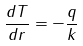Convert formula to latex. <formula><loc_0><loc_0><loc_500><loc_500>\frac { d T } { d r } = - \frac { q } { k }</formula> 